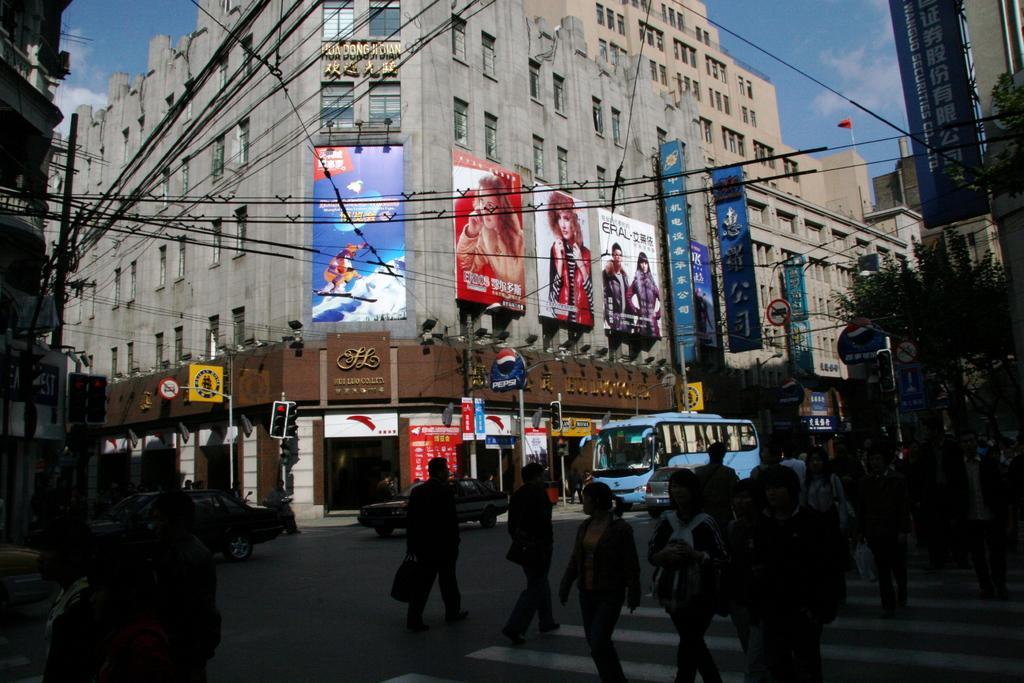Describe this image in one or two sentences. In this image I can see few buildings,glass windows,lights,banners,signboards,traffic signals,few stores,flag,current poles,wires,few vehicles and few people walking on the road. The sky is in white and blue color 